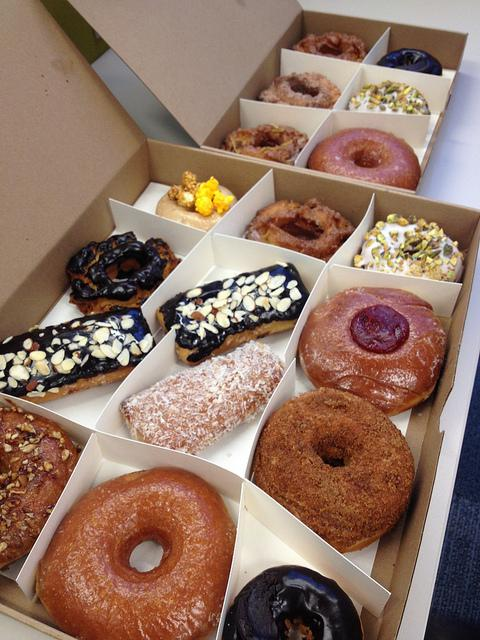What is the most common topping on the frosting?

Choices:
A) popcorn
B) nuts
C) jelly
D) powdered sugar nuts 